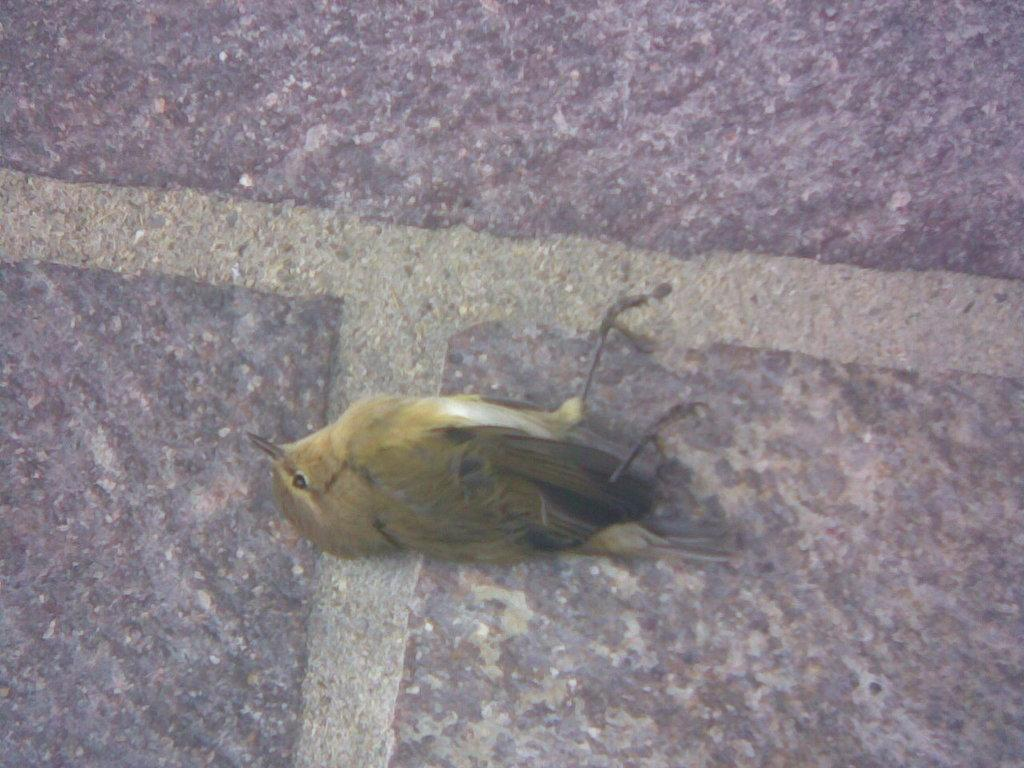What type of animal can be seen in the image? There is a bird in the image. What is the bird lying on? The bird is lying on a stone surface. What type of plantation is visible in the background of the image? There is no plantation visible in the image; it only features a bird lying on a stone surface. 